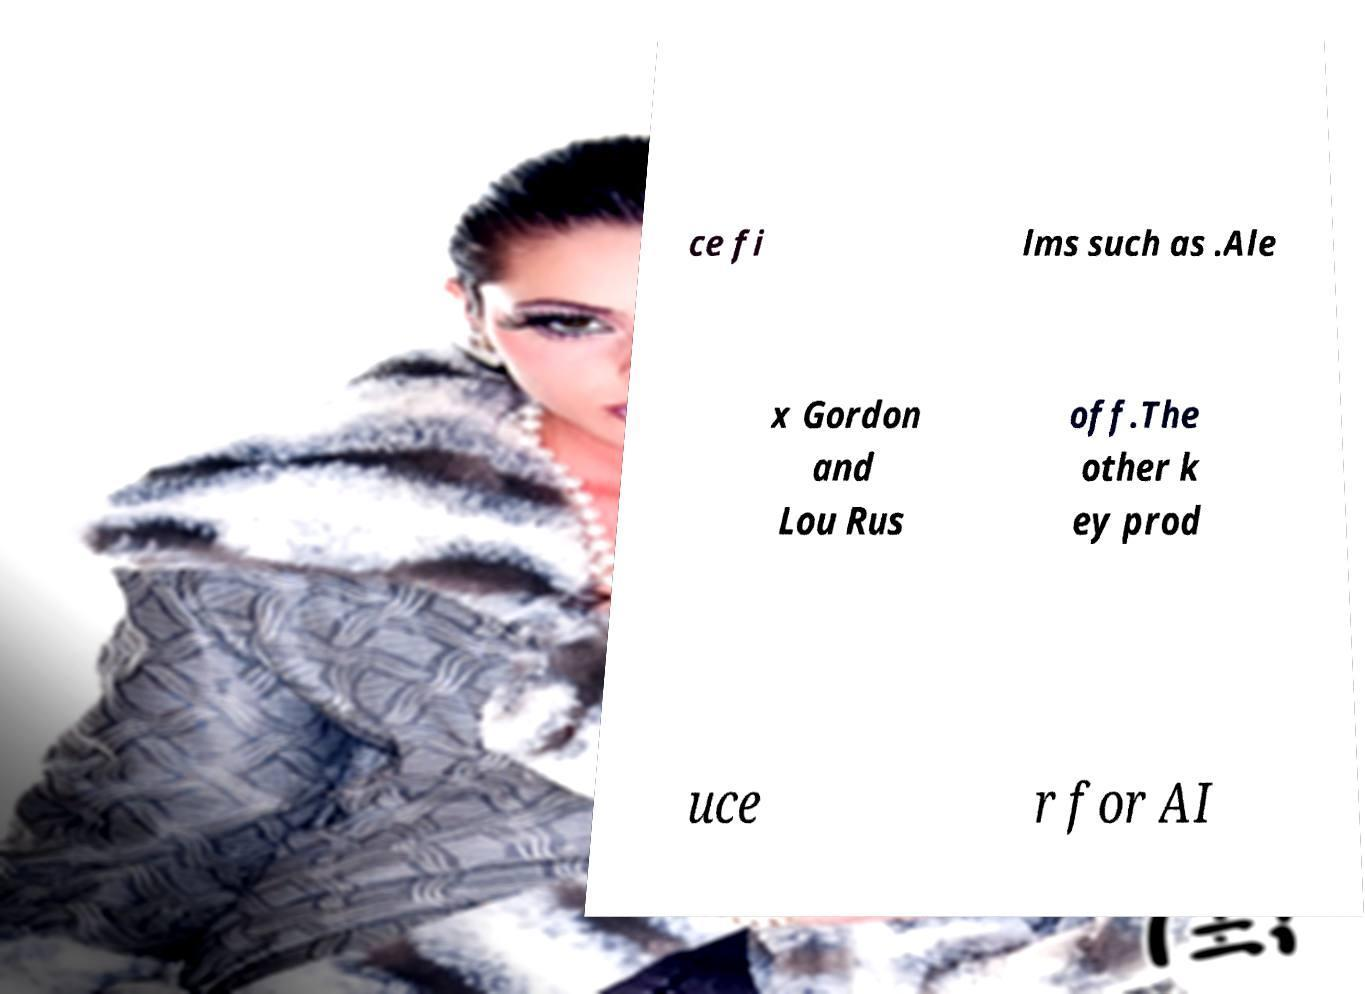For documentation purposes, I need the text within this image transcribed. Could you provide that? ce fi lms such as .Ale x Gordon and Lou Rus off.The other k ey prod uce r for AI 